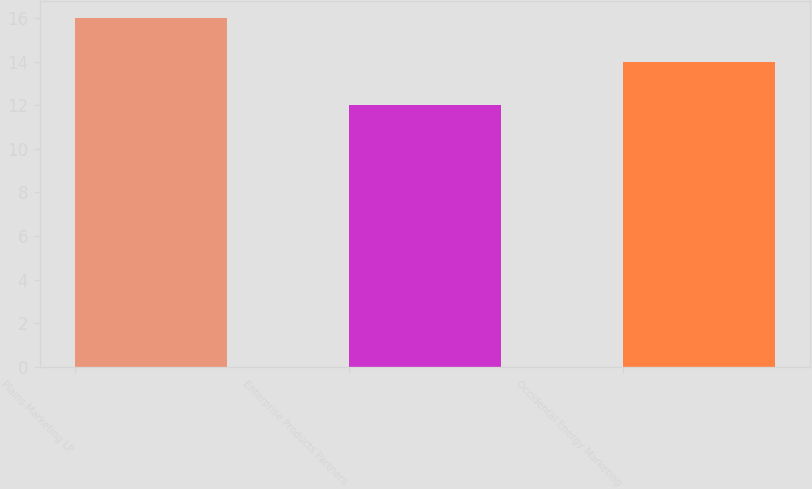Convert chart to OTSL. <chart><loc_0><loc_0><loc_500><loc_500><bar_chart><fcel>Plains Marketing LP<fcel>Enterprise Products Partners<fcel>Occidental Energy Marketing<nl><fcel>16<fcel>12<fcel>14<nl></chart> 